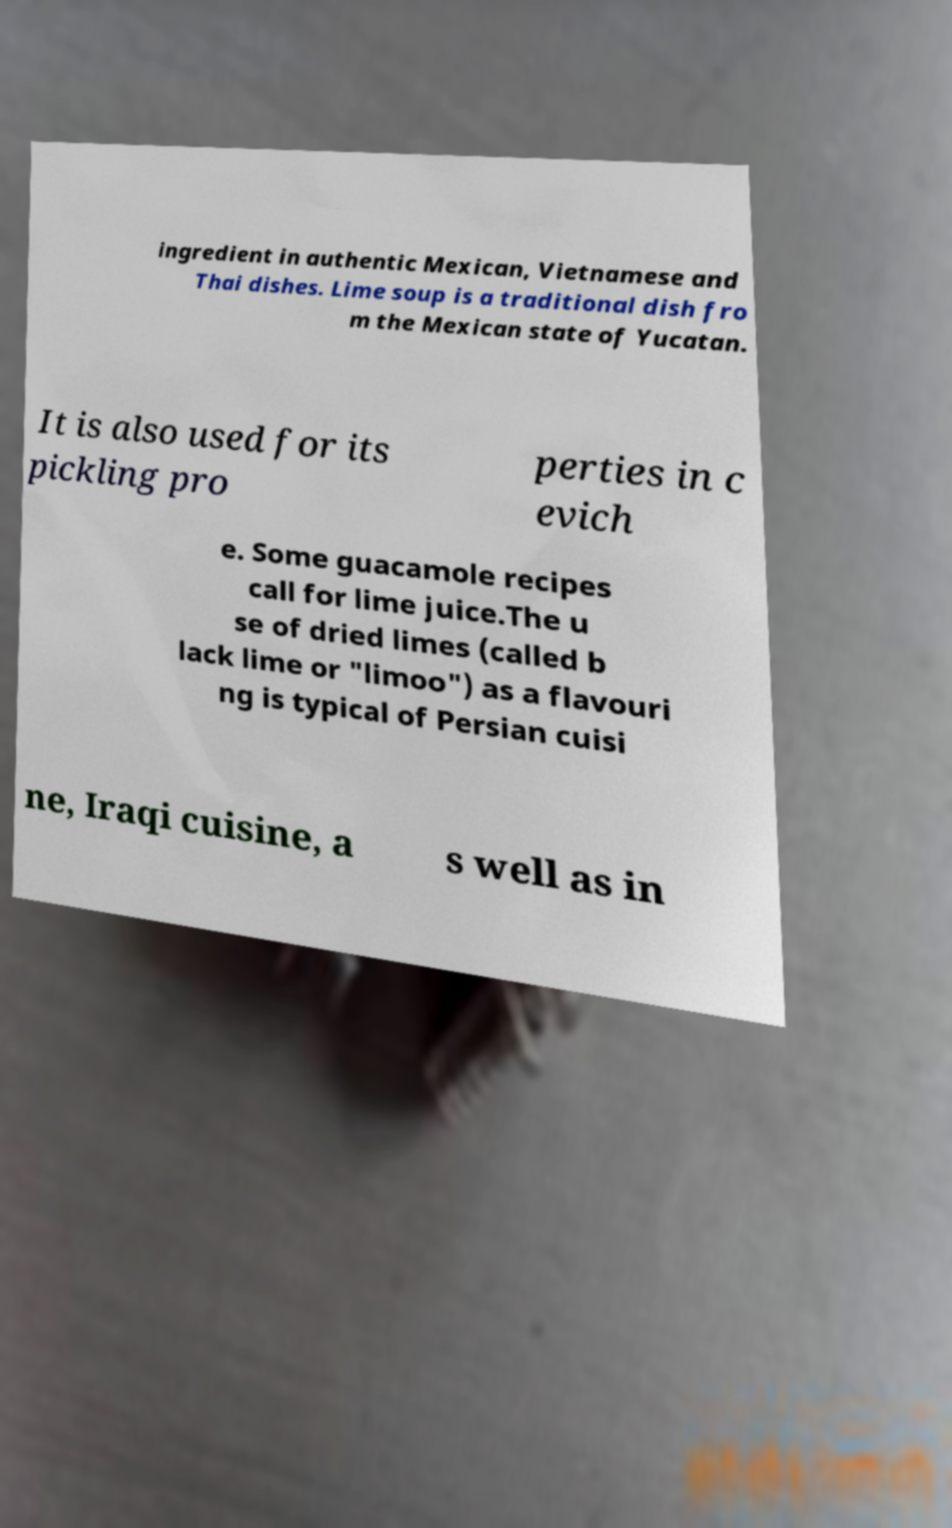Could you assist in decoding the text presented in this image and type it out clearly? ingredient in authentic Mexican, Vietnamese and Thai dishes. Lime soup is a traditional dish fro m the Mexican state of Yucatan. It is also used for its pickling pro perties in c evich e. Some guacamole recipes call for lime juice.The u se of dried limes (called b lack lime or "limoo") as a flavouri ng is typical of Persian cuisi ne, Iraqi cuisine, a s well as in 